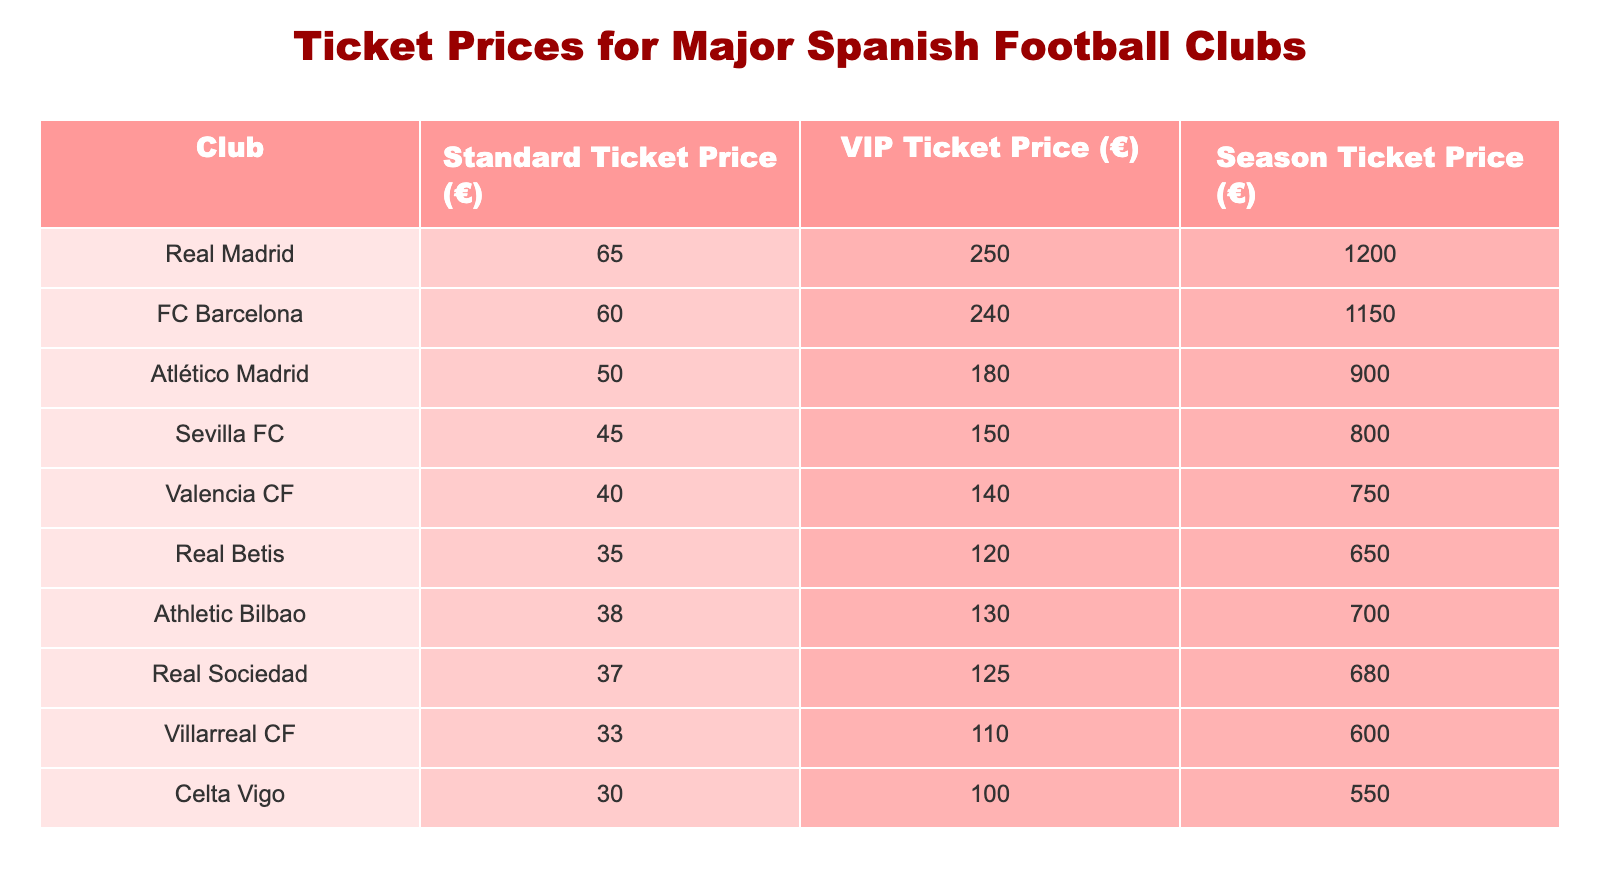What is the standard ticket price for Real Madrid? The table shows that the standard ticket price for Real Madrid is 65 euros.
Answer: 65 Which club has the cheapest standard ticket price? By looking through the standard ticket prices, Real Betis has the lowest price at 35 euros.
Answer: Real Betis What is the difference in VIP ticket price between FC Barcelona and Atlético Madrid? FC Barcelona's VIP ticket price is 240 euros and Atlético Madrid's is 180 euros. The difference is calculated as 240 - 180 = 60 euros.
Answer: 60 Which two clubs have VIP ticket prices under 150 euros? By examining the VIP ticket prices, Sevilla FC (150 euros) and Real Betis (120 euros) are the only two with prices under 150 euros.
Answer: Sevilla FC and Real Betis What is the average standard ticket price for the top three clubs by price? The top three clubs by standard ticket price are Real Madrid (65 euros), FC Barcelona (60 euros), and Atlético Madrid (50 euros). The average is calculated as (65 + 60 + 50) / 3 = 58.33 euros, which rounds to 58.33.
Answer: 58.33 Is the season ticket price for Valencia CF higher than that of Real Betis? Valencia CF's season ticket price is 750 euros, while Real Betis's is 650 euros. Since 750 is greater than 650, the statement is true.
Answer: Yes What is the total season ticket price for the four clubs with the highest prices? The clubs with the highest season ticket prices are Real Madrid (1200 euros), FC Barcelona (1150 euros), Atlético Madrid (900 euros), and Sevilla FC (800 euros). Summing these gives us 1200 + 1150 + 900 + 800 = 4050 euros.
Answer: 4050 Which club has both the highest standard ticket price and highest season ticket price? Real Madrid has the highest standard ticket price at 65 euros and the highest season ticket price at 1200 euros, making it the only club with both highest prices.
Answer: Real Madrid Is the standard ticket price of Athletic Bilbao less than the average standard ticket price of all clubs? The average price needs to be calculated first. The total of all standard ticket prices is 65 + 60 + 50 + 45 + 40 + 35 + 38 + 37 + 33 + 30 = 453 euros. There are 10 clubs, so the average is 453 / 10 = 45.3 euros. Athletic Bilbao's standard ticket price is 38 euros, which is less than 45.3 euros. Therefore, the answer is true.
Answer: Yes 